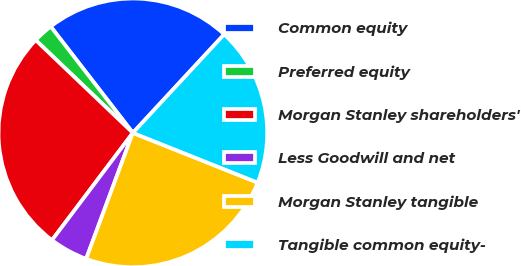<chart> <loc_0><loc_0><loc_500><loc_500><pie_chart><fcel>Common equity<fcel>Preferred equity<fcel>Morgan Stanley shareholders'<fcel>Less Goodwill and net<fcel>Morgan Stanley tangible<fcel>Tangible common equity-<nl><fcel>22.37%<fcel>2.4%<fcel>26.85%<fcel>4.63%<fcel>24.61%<fcel>19.14%<nl></chart> 